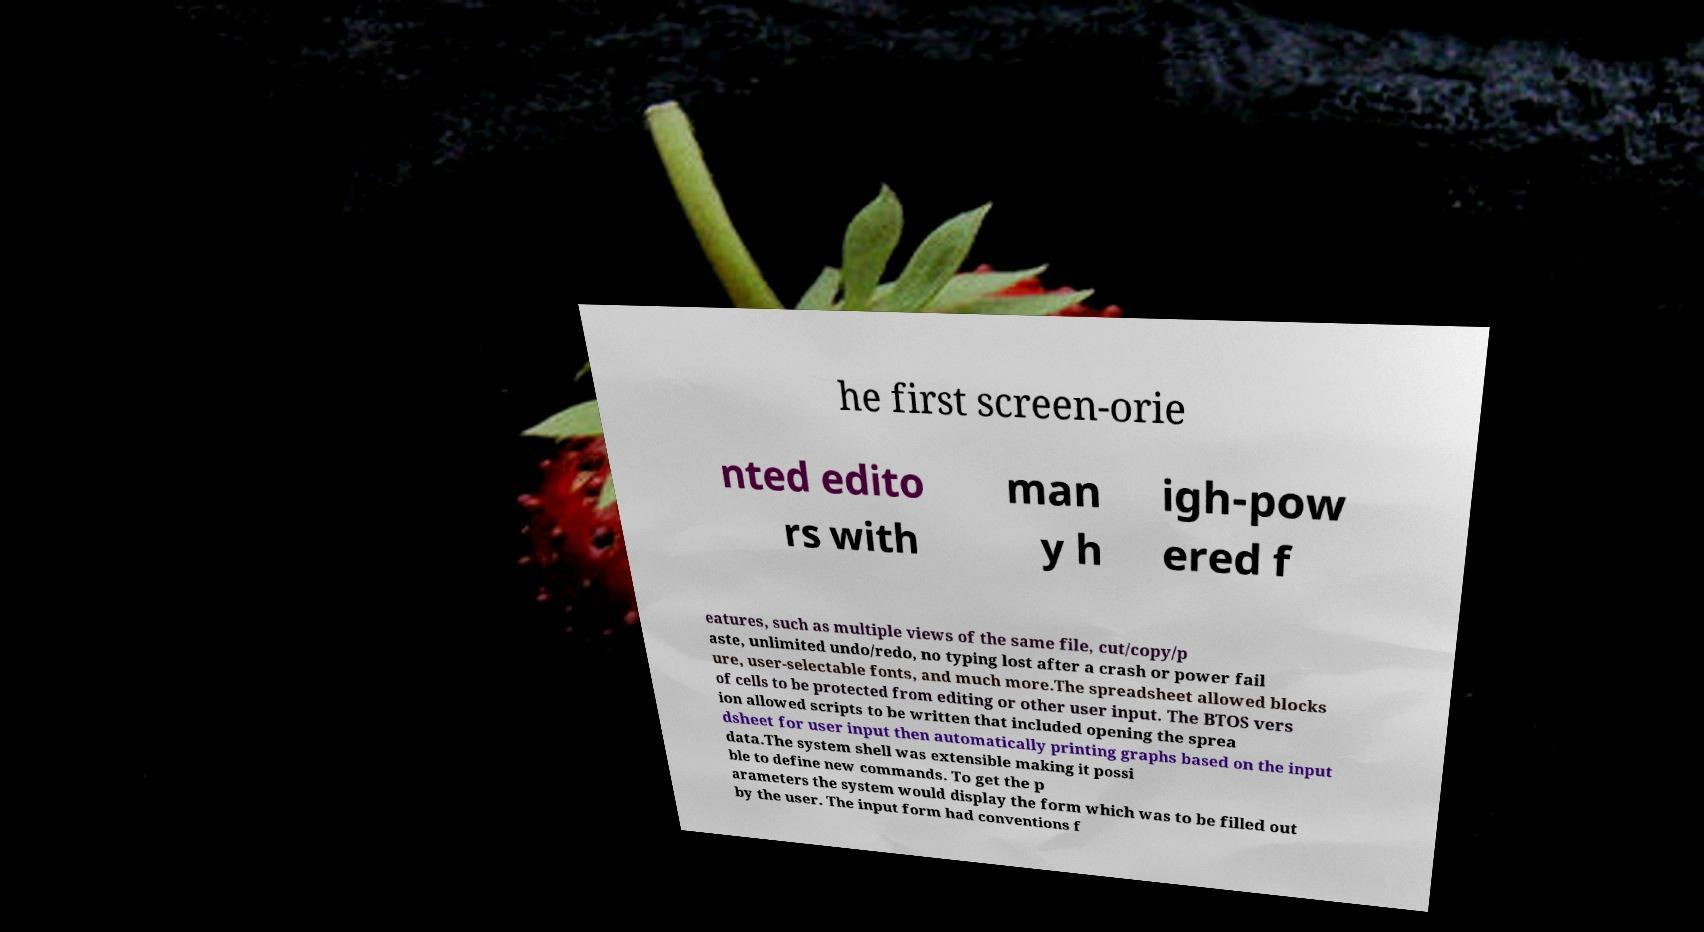What messages or text are displayed in this image? I need them in a readable, typed format. he first screen-orie nted edito rs with man y h igh-pow ered f eatures, such as multiple views of the same file, cut/copy/p aste, unlimited undo/redo, no typing lost after a crash or power fail ure, user-selectable fonts, and much more.The spreadsheet allowed blocks of cells to be protected from editing or other user input. The BTOS vers ion allowed scripts to be written that included opening the sprea dsheet for user input then automatically printing graphs based on the input data.The system shell was extensible making it possi ble to define new commands. To get the p arameters the system would display the form which was to be filled out by the user. The input form had conventions f 